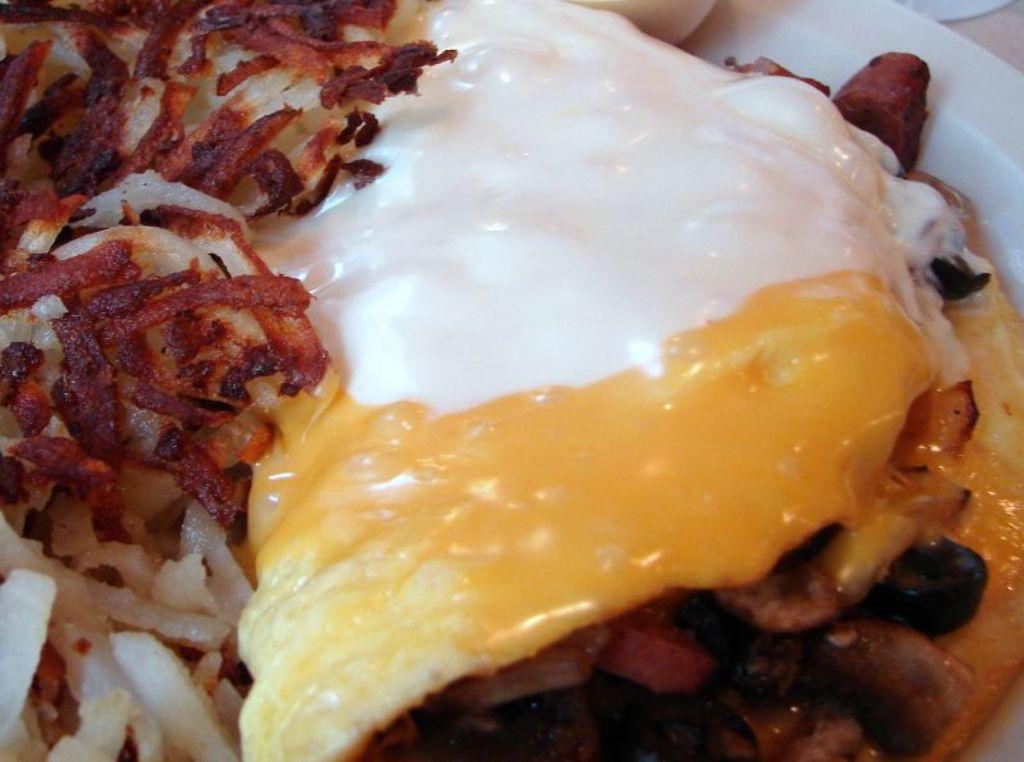Can you describe this image briefly? In this image I can see food in the plate. 